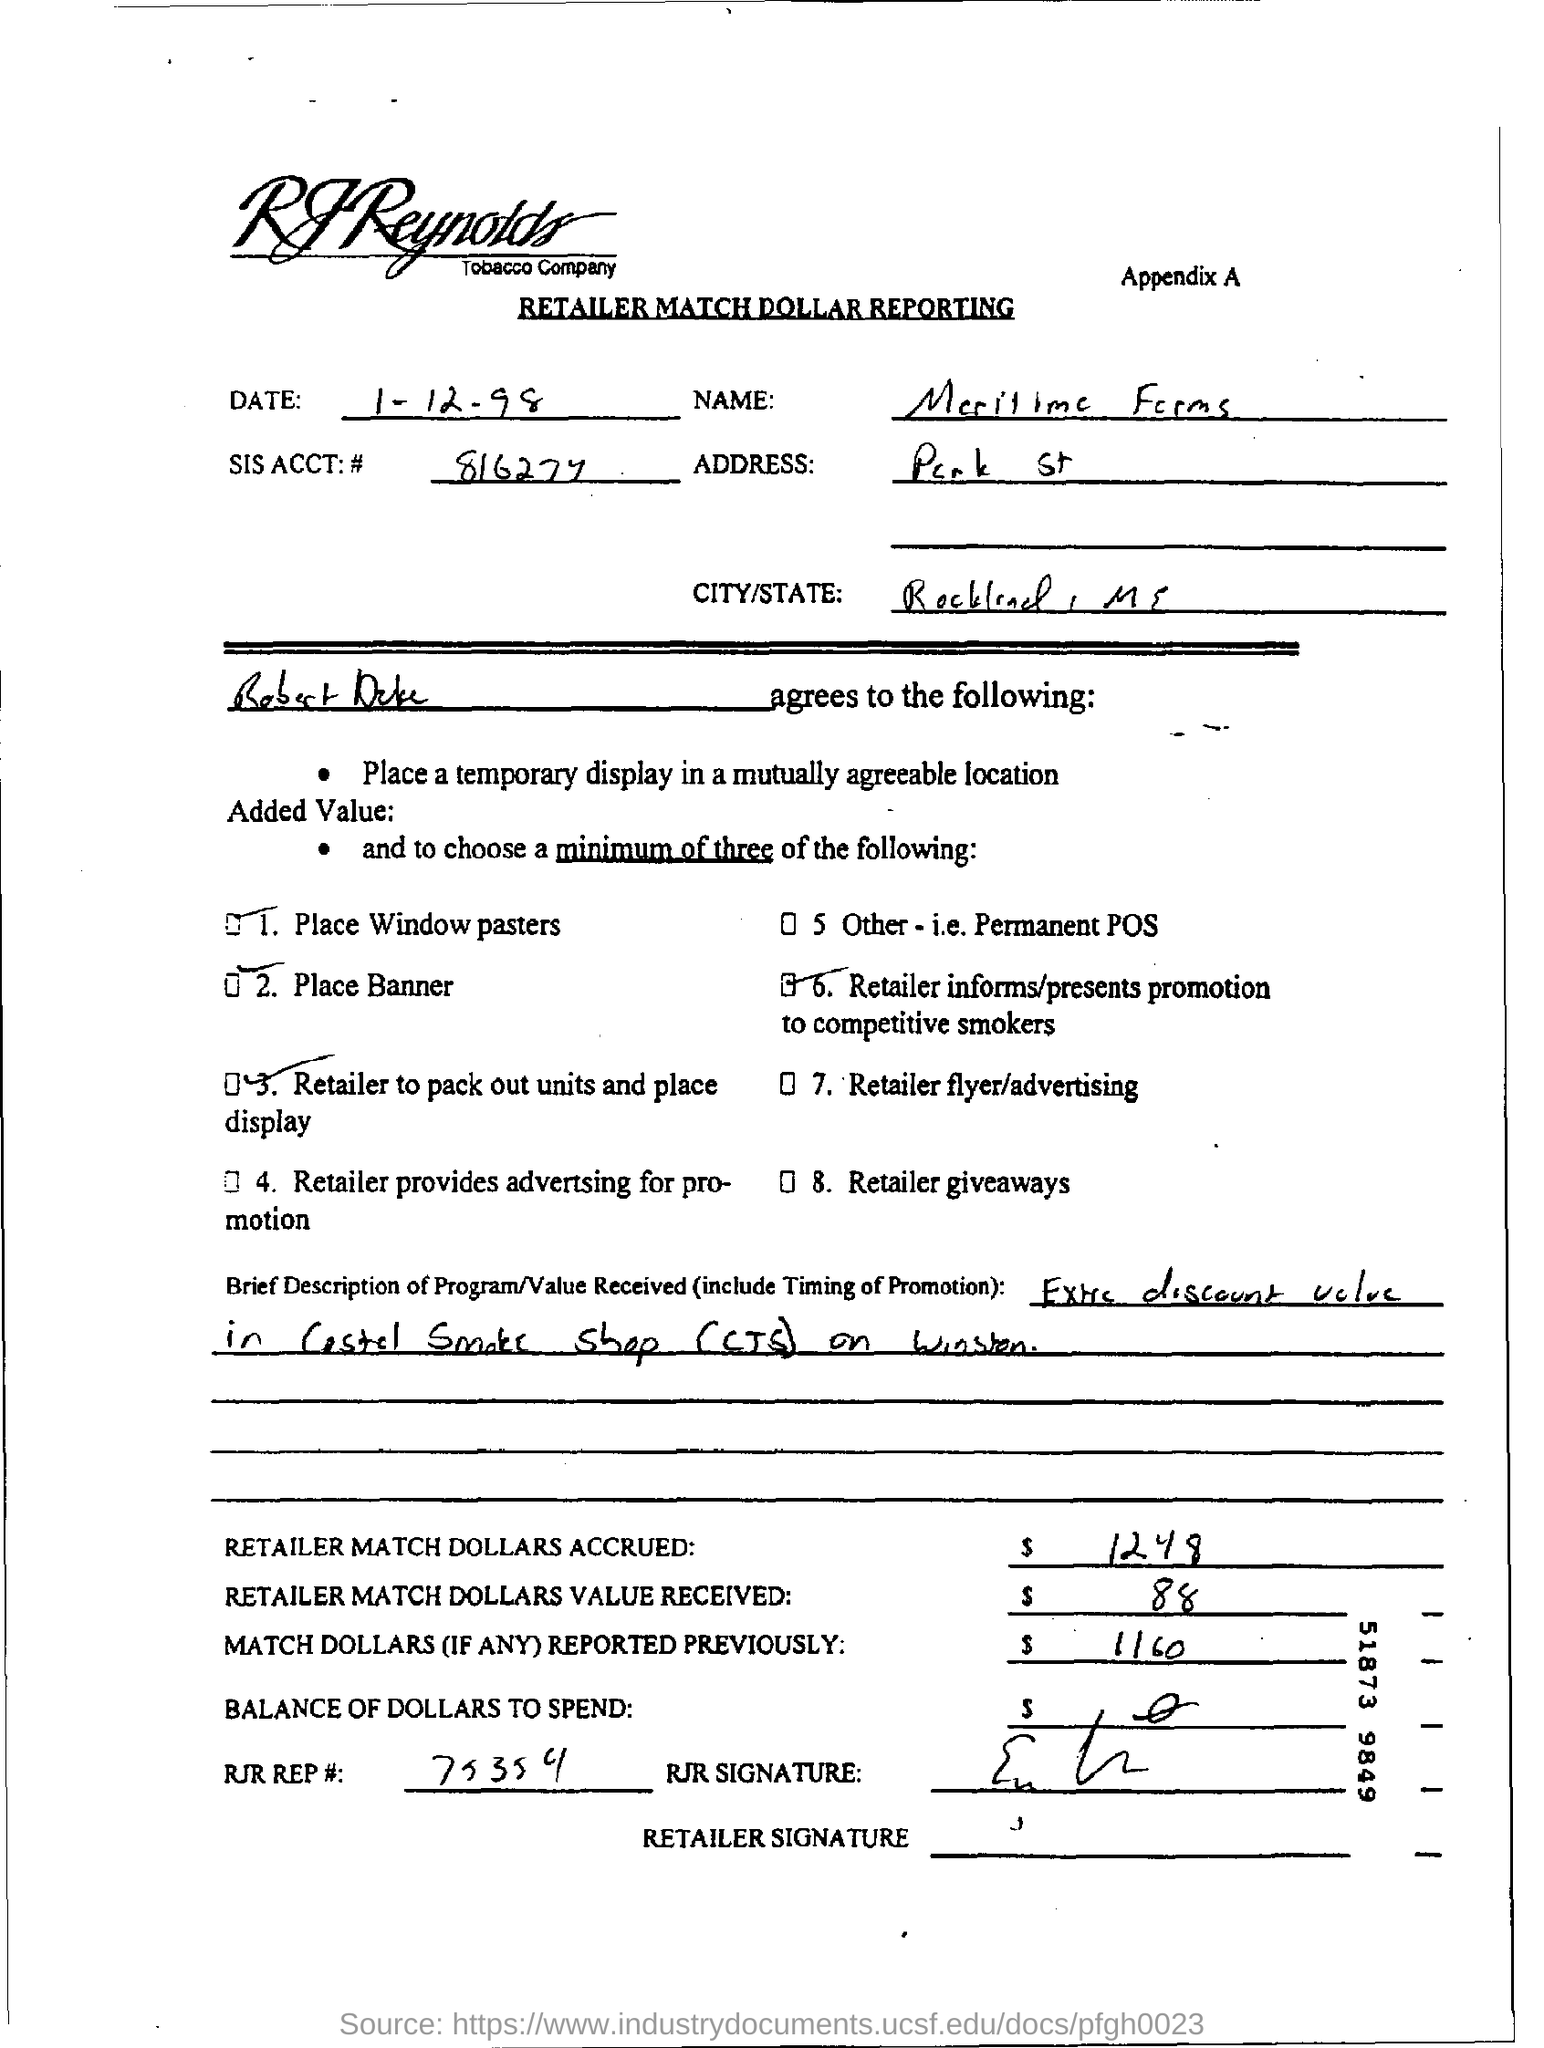Highlight a few significant elements in this photo. This paper belongs to the series of Appendix. 